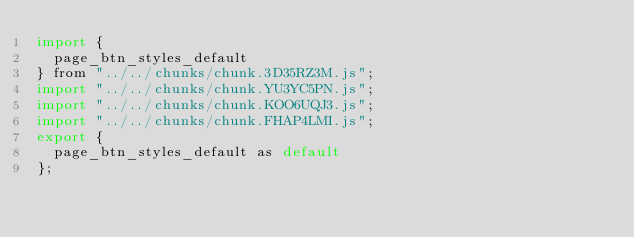Convert code to text. <code><loc_0><loc_0><loc_500><loc_500><_JavaScript_>import {
  page_btn_styles_default
} from "../../chunks/chunk.3D35RZ3M.js";
import "../../chunks/chunk.YU3YC5PN.js";
import "../../chunks/chunk.KOO6UQJ3.js";
import "../../chunks/chunk.FHAP4LMI.js";
export {
  page_btn_styles_default as default
};
</code> 